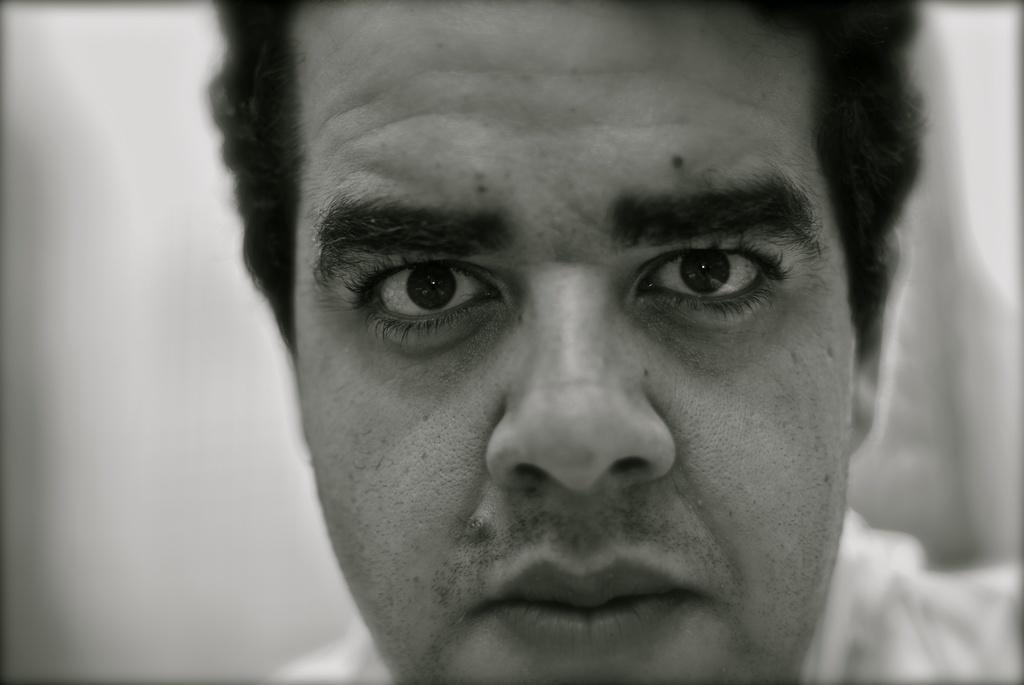Can you describe this image briefly? In this picture we can see a person and in the background we can see it is blurry. 